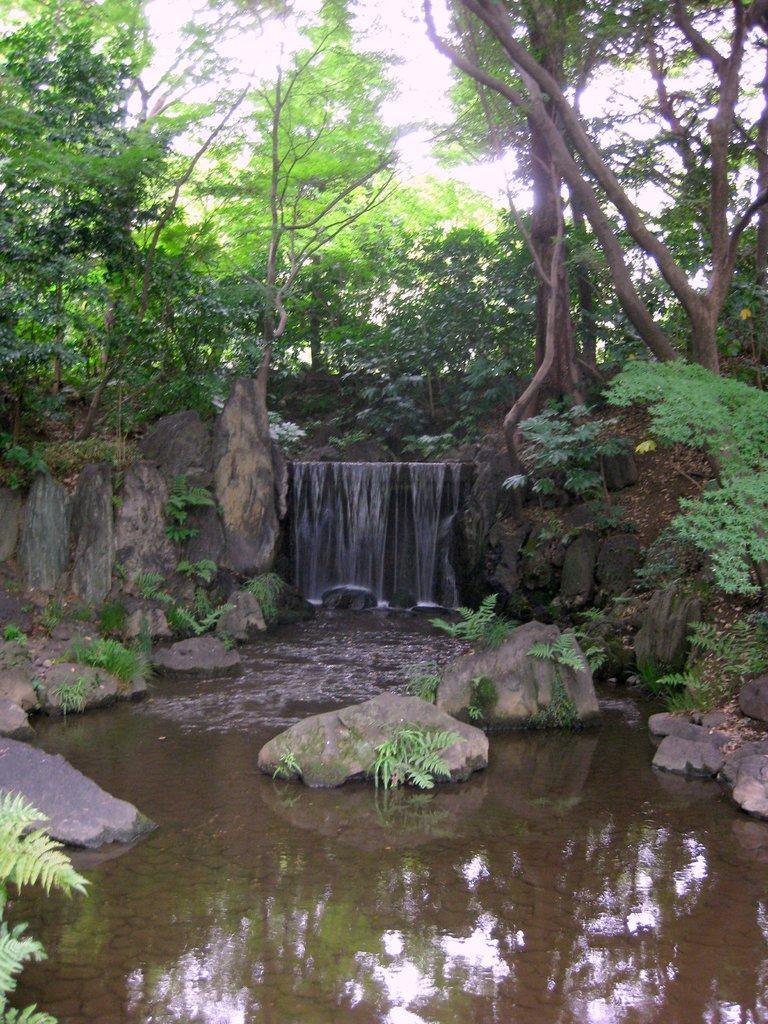Please provide a concise description of this image. In this image we can see some water, stones and in the background of the image there are some trees and clear sky. 